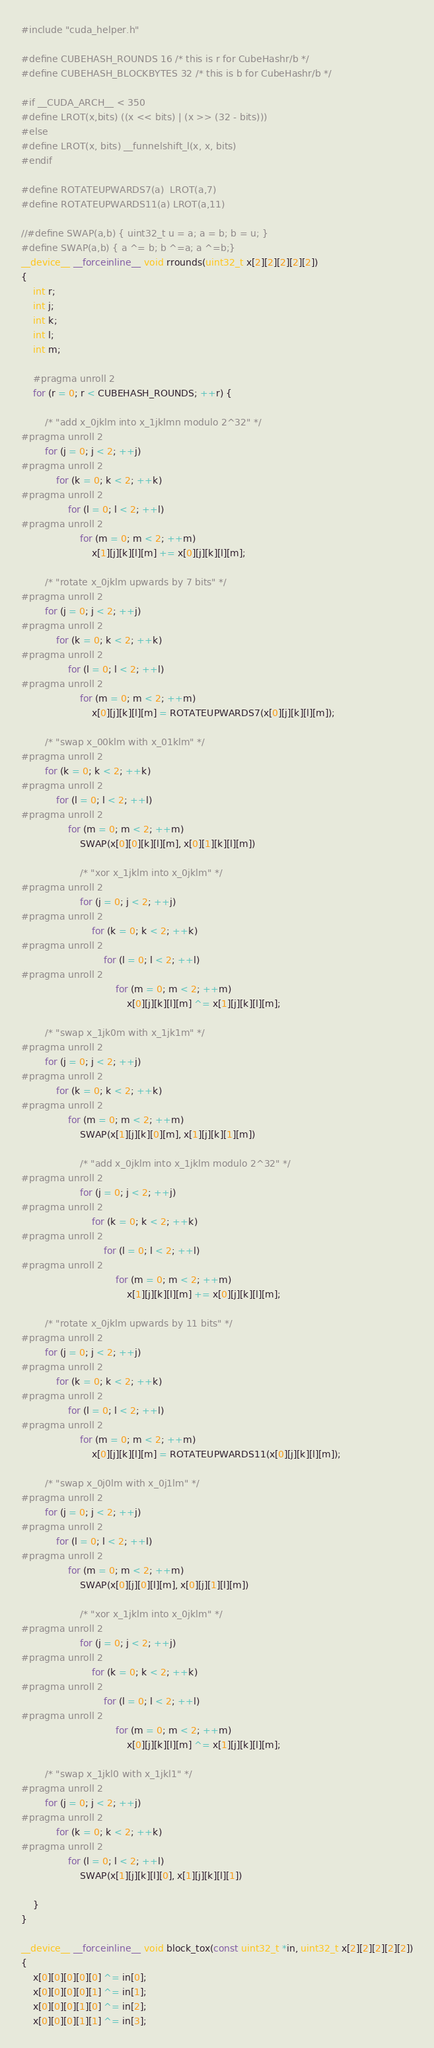Convert code to text. <code><loc_0><loc_0><loc_500><loc_500><_Cuda_>#include "cuda_helper.h"

#define CUBEHASH_ROUNDS 16 /* this is r for CubeHashr/b */
#define CUBEHASH_BLOCKBYTES 32 /* this is b for CubeHashr/b */

#if __CUDA_ARCH__ < 350
#define LROT(x,bits) ((x << bits) | (x >> (32 - bits)))
#else
#define LROT(x, bits) __funnelshift_l(x, x, bits)
#endif

#define ROTATEUPWARDS7(a)  LROT(a,7)
#define ROTATEUPWARDS11(a) LROT(a,11)

//#define SWAP(a,b) { uint32_t u = a; a = b; b = u; }
#define SWAP(a,b) { a ^= b; b ^=a; a ^=b;}
__device__ __forceinline__ void rrounds(uint32_t x[2][2][2][2][2])
{
	int r;
	int j;
	int k;
	int l;
	int m;

	#pragma unroll 2
	for (r = 0; r < CUBEHASH_ROUNDS; ++r) {

		/* "add x_0jklm into x_1jklmn modulo 2^32" */
#pragma unroll 2
		for (j = 0; j < 2; ++j)
#pragma unroll 2
			for (k = 0; k < 2; ++k)
#pragma unroll 2
				for (l = 0; l < 2; ++l)
#pragma unroll 2
					for (m = 0; m < 2; ++m)
						x[1][j][k][l][m] += x[0][j][k][l][m];

		/* "rotate x_0jklm upwards by 7 bits" */
#pragma unroll 2
		for (j = 0; j < 2; ++j)
#pragma unroll 2
			for (k = 0; k < 2; ++k)
#pragma unroll 2
				for (l = 0; l < 2; ++l)
#pragma unroll 2
					for (m = 0; m < 2; ++m)
						x[0][j][k][l][m] = ROTATEUPWARDS7(x[0][j][k][l][m]);

		/* "swap x_00klm with x_01klm" */
#pragma unroll 2
		for (k = 0; k < 2; ++k)
#pragma unroll 2
			for (l = 0; l < 2; ++l)
#pragma unroll 2
				for (m = 0; m < 2; ++m)
					SWAP(x[0][0][k][l][m], x[0][1][k][l][m])

					/* "xor x_1jklm into x_0jklm" */
#pragma unroll 2
					for (j = 0; j < 2; ++j)
#pragma unroll 2
						for (k = 0; k < 2; ++k)
#pragma unroll 2
							for (l = 0; l < 2; ++l)
#pragma unroll 2
								for (m = 0; m < 2; ++m)
									x[0][j][k][l][m] ^= x[1][j][k][l][m];

		/* "swap x_1jk0m with x_1jk1m" */
#pragma unroll 2
		for (j = 0; j < 2; ++j)
#pragma unroll 2
			for (k = 0; k < 2; ++k)
#pragma unroll 2
				for (m = 0; m < 2; ++m)
					SWAP(x[1][j][k][0][m], x[1][j][k][1][m])

					/* "add x_0jklm into x_1jklm modulo 2^32" */
#pragma unroll 2
					for (j = 0; j < 2; ++j)
#pragma unroll 2
						for (k = 0; k < 2; ++k)
#pragma unroll 2
							for (l = 0; l < 2; ++l)
#pragma unroll 2
								for (m = 0; m < 2; ++m)
									x[1][j][k][l][m] += x[0][j][k][l][m];

		/* "rotate x_0jklm upwards by 11 bits" */
#pragma unroll 2
		for (j = 0; j < 2; ++j)
#pragma unroll 2
			for (k = 0; k < 2; ++k)
#pragma unroll 2
				for (l = 0; l < 2; ++l)
#pragma unroll 2
					for (m = 0; m < 2; ++m)
						x[0][j][k][l][m] = ROTATEUPWARDS11(x[0][j][k][l][m]);

		/* "swap x_0j0lm with x_0j1lm" */
#pragma unroll 2
		for (j = 0; j < 2; ++j)
#pragma unroll 2
			for (l = 0; l < 2; ++l)
#pragma unroll 2
				for (m = 0; m < 2; ++m)
					SWAP(x[0][j][0][l][m], x[0][j][1][l][m])

					/* "xor x_1jklm into x_0jklm" */
#pragma unroll 2
					for (j = 0; j < 2; ++j)
#pragma unroll 2
						for (k = 0; k < 2; ++k)
#pragma unroll 2
							for (l = 0; l < 2; ++l)
#pragma unroll 2
								for (m = 0; m < 2; ++m)
									x[0][j][k][l][m] ^= x[1][j][k][l][m];

		/* "swap x_1jkl0 with x_1jkl1" */
#pragma unroll 2
		for (j = 0; j < 2; ++j)
#pragma unroll 2
			for (k = 0; k < 2; ++k)
#pragma unroll 2
				for (l = 0; l < 2; ++l)
					SWAP(x[1][j][k][l][0], x[1][j][k][l][1])

	}
}

__device__ __forceinline__ void block_tox(const uint32_t *in, uint32_t x[2][2][2][2][2])
{
	x[0][0][0][0][0] ^= in[0];
	x[0][0][0][0][1] ^= in[1];
	x[0][0][0][1][0] ^= in[2];
	x[0][0][0][1][1] ^= in[3];</code> 